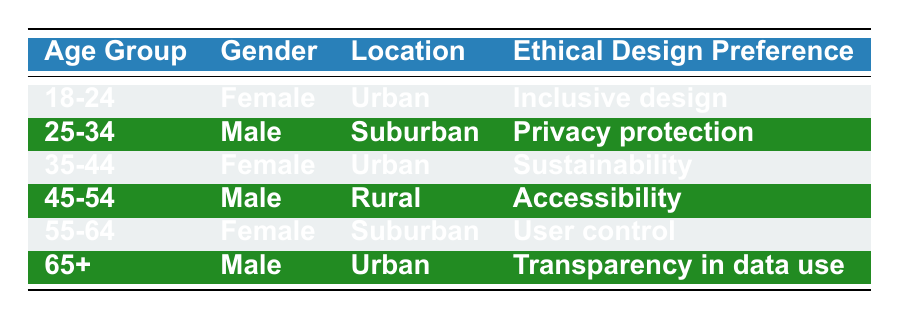What ethical design preference do females in the age group 35-44 have? According to the table, the only female in the age group 35-44 has the ethical design preference of sustainability.
Answer: Sustainability How many males prefer transparency in data use? In the table, there is only one male who has the preference for transparency in data use, and he belongs to the age group 65+.
Answer: 1 Is privacy protection preferred by users located in urban areas? The table shows that privacy protection is preferred by a male in the age group 25-34 who is located in the suburban area, indicating that no users in urban areas prefer privacy protection.
Answer: No What is the most common ethical design preference among users aged 55-64? According to the table, the only user in the age group 55-64 is a female who prefers user control, making it the most common preference for this age group.
Answer: User control Are there more males or females preferring inclusive design? The table indicates that only one female, aged 18-24, has a preference for inclusive design while no males are noted as preferring it. Thus, there are more females.
Answer: More females What is the age group of users who prefer accessibility? The table lists accessibility as the preference for the male user in the age group 45-54, making this user the only one in this preference category.
Answer: 45-54 What is the average age of users who prefer sustainability and accessibility combined? The user who prefers sustainability is in the age group 35-44, while the user who prefers accessibility is in the age group 45-54. Converting these ranges to averages: 35-44 averages to 39.5 and 45-54 averages to 49.5. Adding these together gives 89 and dividing by 2 results in an average age of 44.5.
Answer: 44.5 Do all users in urban locations have the same ethical design preference? The table shows two users in urban locations: one female aged 18-24 who prefers inclusive design and one male aged 65+ who prefers transparency in data use. Since they have different preferences, not all users in urban locations share the same preference.
Answer: No Which location has the highest diversity in ethical design preferences based on the table? Looking at the table, we see that both urban locations present two different preferences (inclusive design and transparency in data use), while suburban (privacy protection and user control) and rural (accessibility) have only one each. Hence, urban shows the highest diversity.
Answer: Urban 